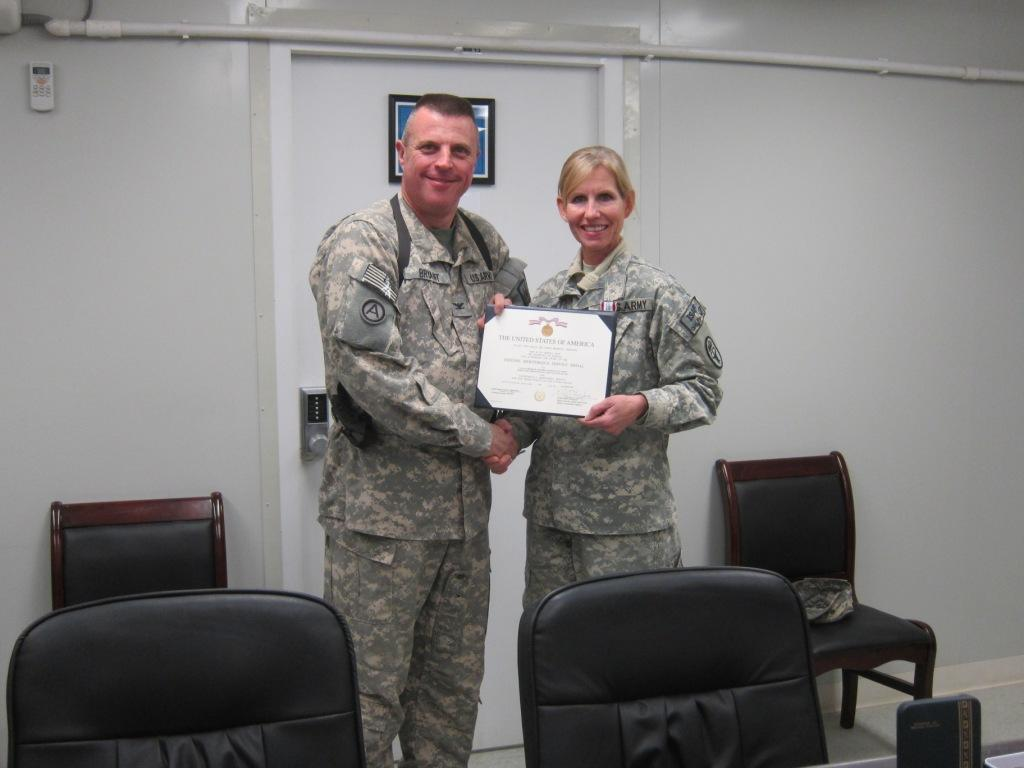How many people are in the image? There are two people in the image, a man and a woman. What are the man and woman doing in the image? Both the man and woman are standing and smiling in the image. What are they holding in their hands? They are holding a certificate in their hands. What type of furniture can be seen in the image? There are chairs in the image. What is the background of the image like? There is a wall in the image, along with a pipe and a frame. What other object is present in the image? There is a remote in the image. What advice is the coach giving to the writer in the image? There is no coach or writer present in the image. The image features a man and a woman holding a certificate, along with other objects and background elements. 